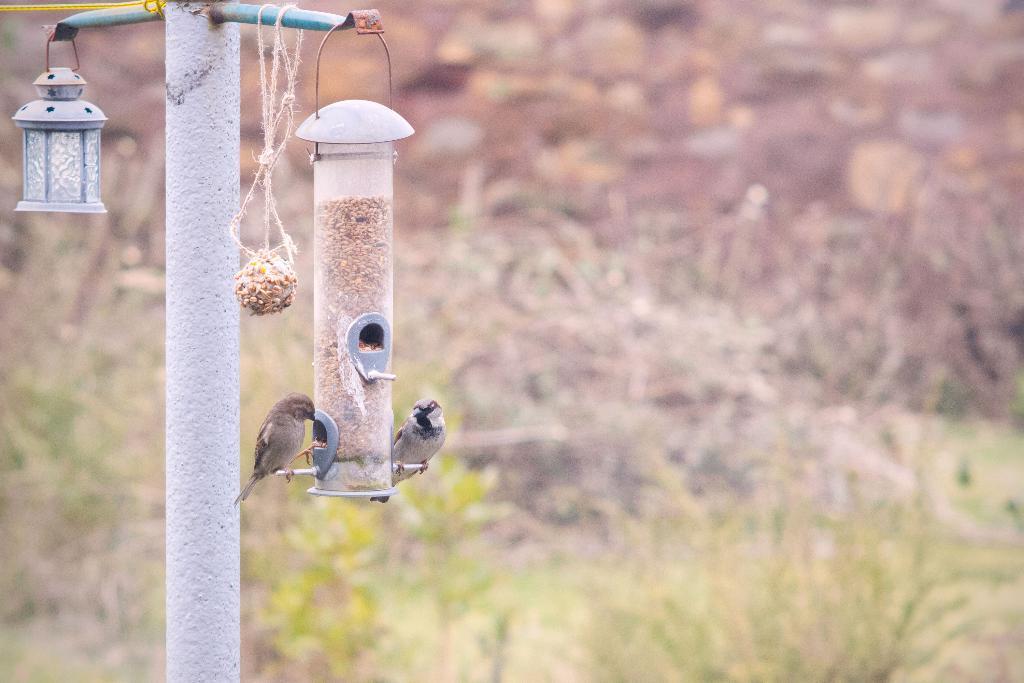Could you give a brief overview of what you see in this image? There are birds on a bird feeding station in the foreground area of the image, it seems like there are plants in the background. 